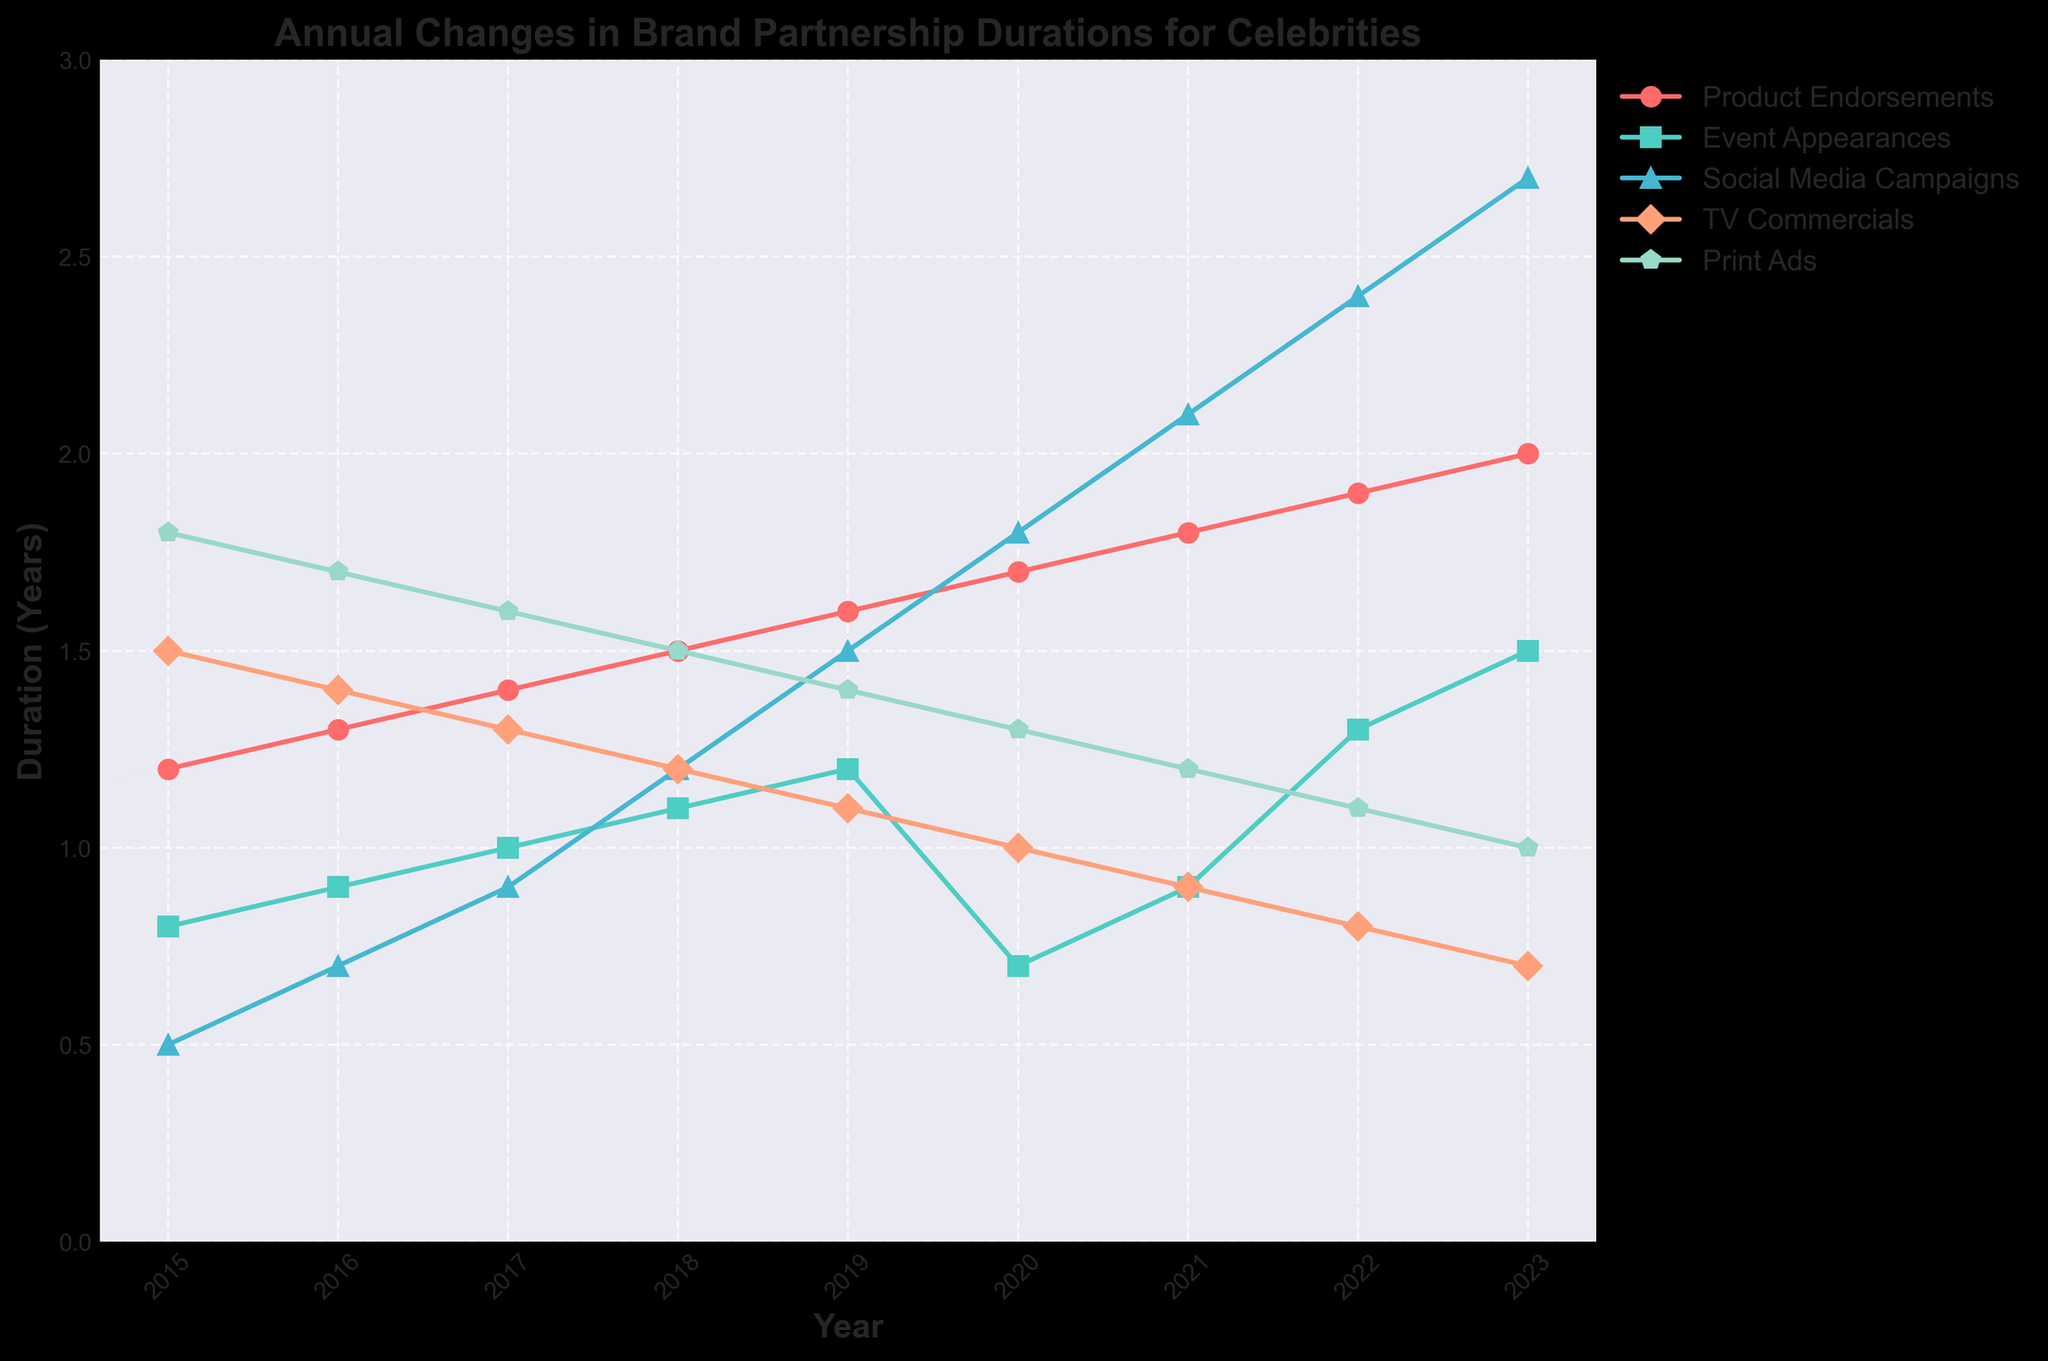What was the duration of TV Commercial endorsements in 2018? Look for the value corresponding to the year 2018 under "TV Commercials".
Answer: 1.2 Which endorsement type had the shortest duration in 2023? Identify the smallest value across all endorsement types for the year 2023.
Answer: Print Ads By how much did the duration of Social Media Campaigns increase from 2017 to 2020? Subtract the value in 2017 from the value in 2020 for Social Media Campaigns. 2.3 (1.8 - 0.9).
Answer: 0.9 What was the overall trend for Print Ads from 2015 to 2023? Note the values for Print Ads from 2015 to 2023. They consistently decreased each year.
Answer: Decreasing Compare the durations of Product Endorsements and Event Appearances in 2018. Which was longer? Compare the values for Product Endorsements and Event Appearances in 2018.
Answer: Product Endorsements How did the duration of Event Appearances change from 2016 to 2017? Observe the values of Event Appearances for 2016 and 2017. The values increased slightly from 0.9 to 1.0.
Answer: Increase What is the difference between the longest and shortest endorsement types in 2020? Identify the maximum and minimum values for 2020 and find the difference. (Highest: Product Endorsements at 1.7, Lowest: TV Commercials at 1.0). The difference is 1.7 - 1.0 = 0.7.
Answer: 0.7 Which endorsement type had the most significant increase over the period 2015 to 2023? Observe the changes over time for each endorsement type from 2015 to 2023. Social Media Campaigns increased the most, from 0.5 to 2.7.
Answer: Social Media Campaigns In which year did the duration of Print Ads and TV Commercials equal each other? Identify the year(s) when the values under Print Ads and TV Commercials are equal. In 2020, both durations are 1.0.
Answer: 2020 Compare the cumulative duration of Product Endorsements and Social Media Campaigns across all years. Which is higher? Add up all the values from 2015 to 2023 for both Product Endorsements and Social Media Campaigns. Product Endorsements: 1.2 + 1.3 + 1.4 + 1.5 + 1.6 + 1.7 + 1.8 + 1.9 + 2.0 = 14.4. Social Media Campaigns: 0.5 + 0.7 + 0.9 + 1.2 + 1.5 + 1.8 + 2.1 + 2.4 + 2.7 = 13.8. Therefore, Product Endorsements had a higher cumulative duration.
Answer: Product Endorsements 